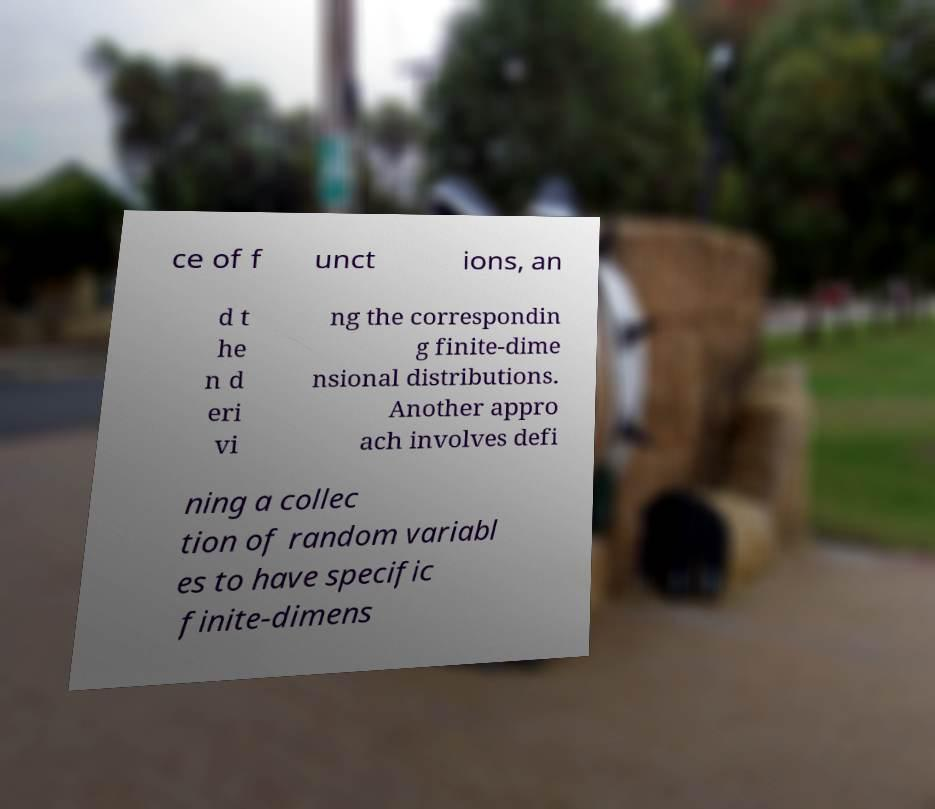Can you read and provide the text displayed in the image?This photo seems to have some interesting text. Can you extract and type it out for me? ce of f unct ions, an d t he n d eri vi ng the correspondin g finite-dime nsional distributions. Another appro ach involves defi ning a collec tion of random variabl es to have specific finite-dimens 